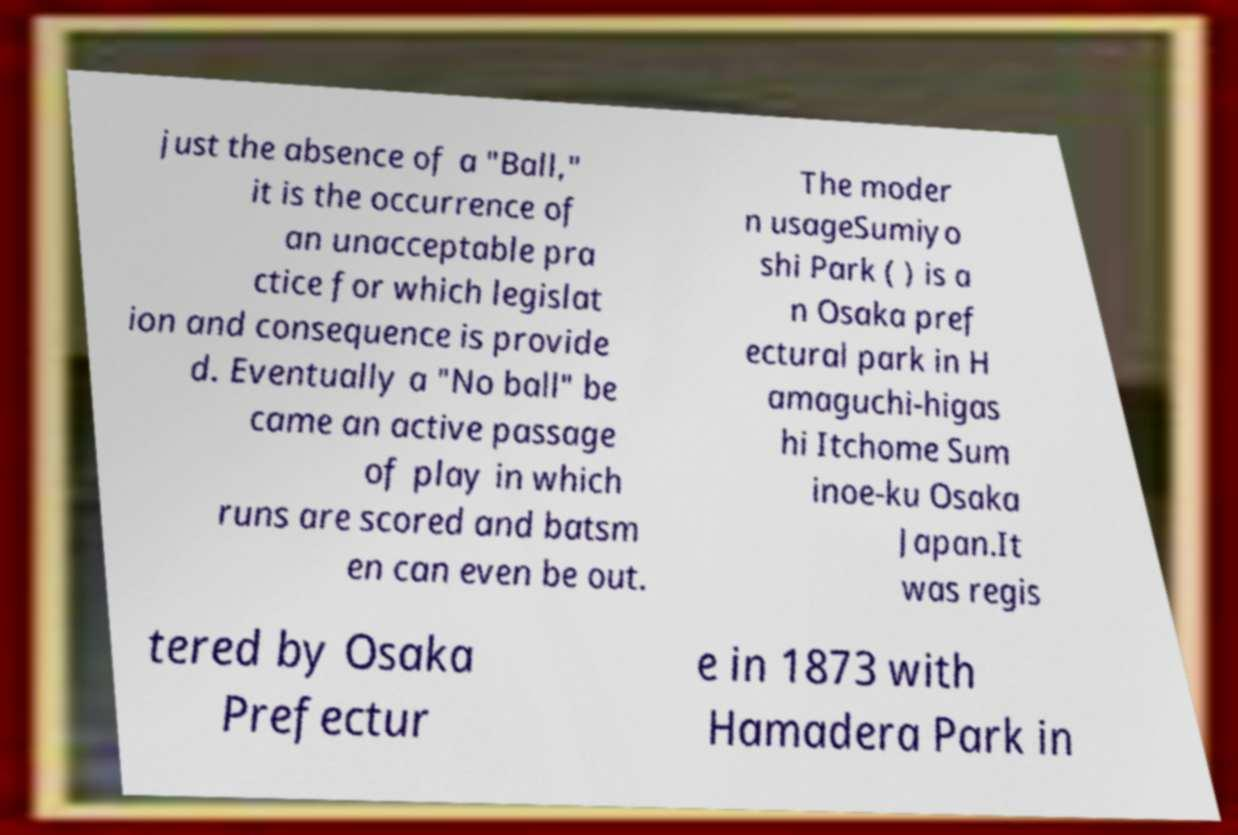For documentation purposes, I need the text within this image transcribed. Could you provide that? just the absence of a "Ball," it is the occurrence of an unacceptable pra ctice for which legislat ion and consequence is provide d. Eventually a "No ball" be came an active passage of play in which runs are scored and batsm en can even be out. The moder n usageSumiyo shi Park ( ) is a n Osaka pref ectural park in H amaguchi-higas hi Itchome Sum inoe-ku Osaka Japan.It was regis tered by Osaka Prefectur e in 1873 with Hamadera Park in 